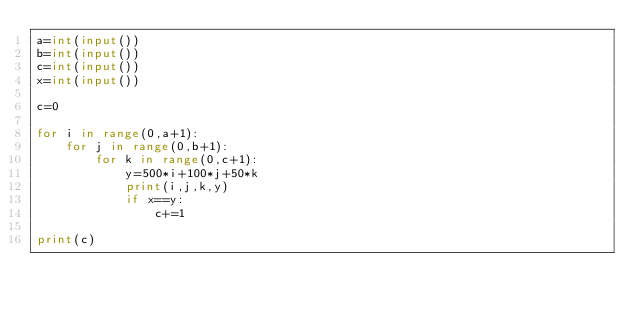Convert code to text. <code><loc_0><loc_0><loc_500><loc_500><_Python_>a=int(input())
b=int(input())
c=int(input())
x=int(input())

c=0

for i in range(0,a+1):
    for j in range(0,b+1):
        for k in range(0,c+1):
            y=500*i+100*j+50*k
            print(i,j,k,y)
            if x==y:
                c+=1

print(c)</code> 